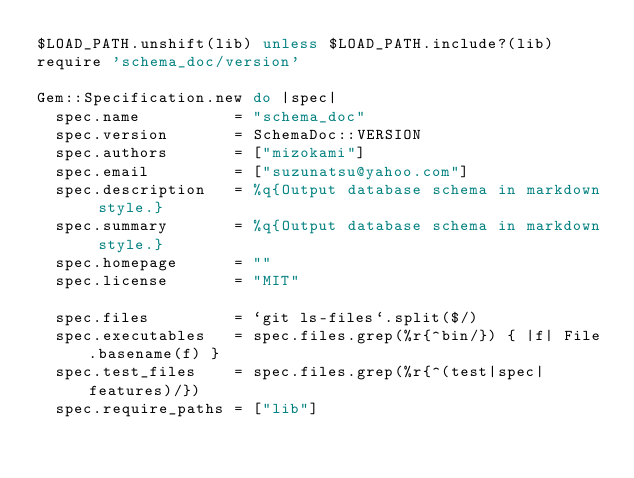Convert code to text. <code><loc_0><loc_0><loc_500><loc_500><_Ruby_>$LOAD_PATH.unshift(lib) unless $LOAD_PATH.include?(lib)
require 'schema_doc/version'

Gem::Specification.new do |spec|
  spec.name          = "schema_doc"
  spec.version       = SchemaDoc::VERSION
  spec.authors       = ["mizokami"]
  spec.email         = ["suzunatsu@yahoo.com"]
  spec.description   = %q{Output database schema in markdown style.}
  spec.summary       = %q{Output database schema in markdown style.}
  spec.homepage      = ""
  spec.license       = "MIT"

  spec.files         = `git ls-files`.split($/)
  spec.executables   = spec.files.grep(%r{^bin/}) { |f| File.basename(f) }
  spec.test_files    = spec.files.grep(%r{^(test|spec|features)/})
  spec.require_paths = ["lib"]
</code> 